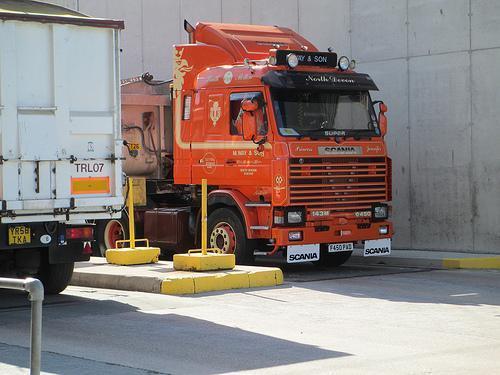How many poles are there?
Give a very brief answer. 2. 